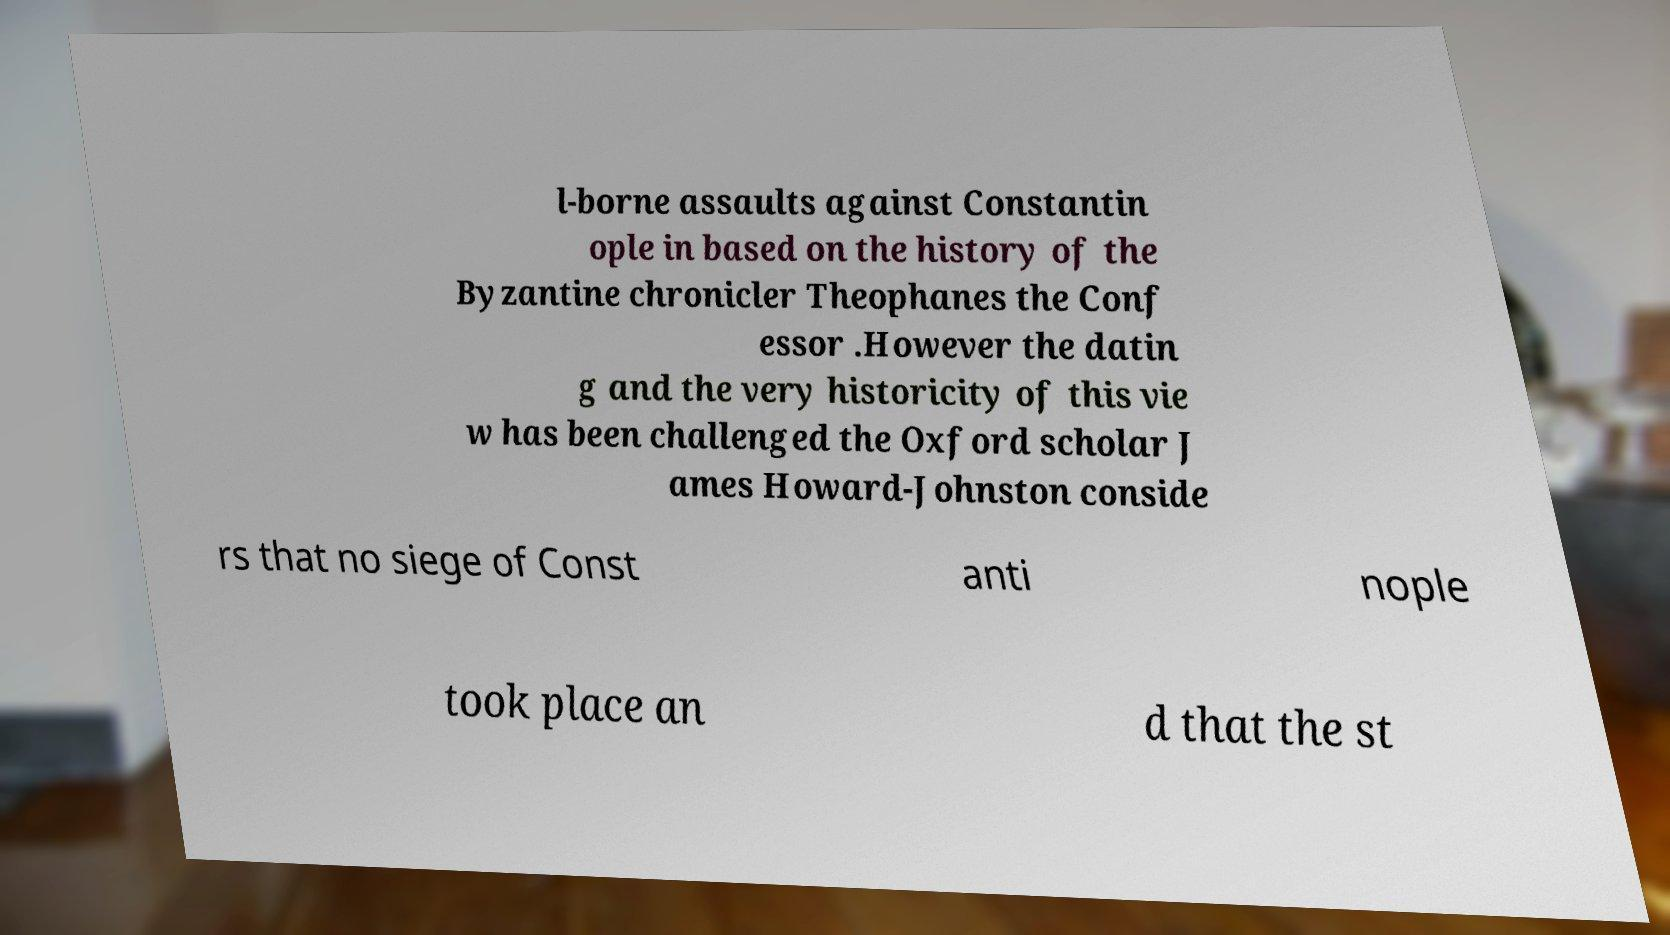Can you accurately transcribe the text from the provided image for me? l-borne assaults against Constantin ople in based on the history of the Byzantine chronicler Theophanes the Conf essor .However the datin g and the very historicity of this vie w has been challenged the Oxford scholar J ames Howard-Johnston conside rs that no siege of Const anti nople took place an d that the st 